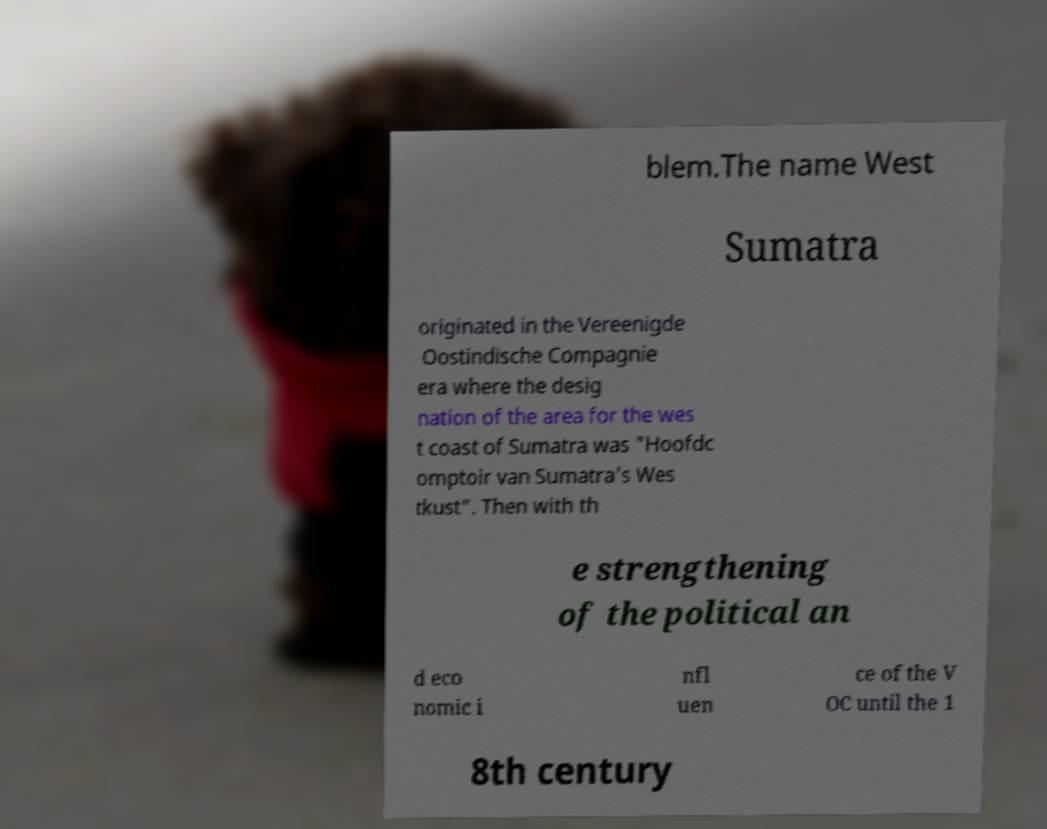Can you accurately transcribe the text from the provided image for me? blem.The name West Sumatra originated in the Vereenigde Oostindische Compagnie era where the desig nation of the area for the wes t coast of Sumatra was "Hoofdc omptoir van Sumatra's Wes tkust". Then with th e strengthening of the political an d eco nomic i nfl uen ce of the V OC until the 1 8th century 